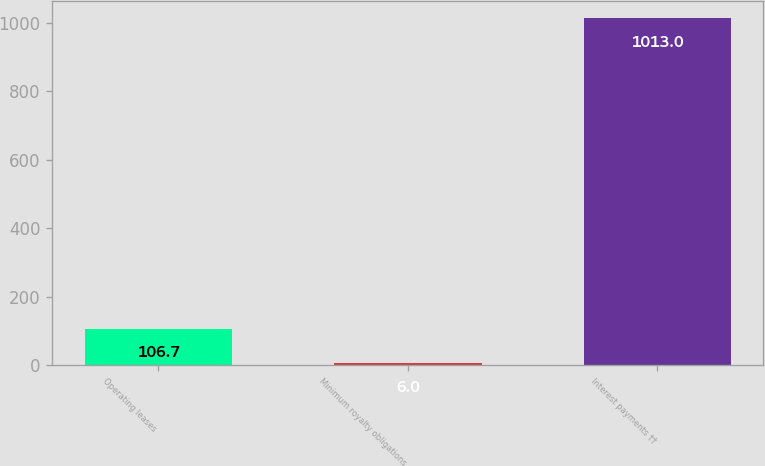<chart> <loc_0><loc_0><loc_500><loc_500><bar_chart><fcel>Operating leases<fcel>Minimum royalty obligations<fcel>Interest payments ††<nl><fcel>106.7<fcel>6<fcel>1013<nl></chart> 